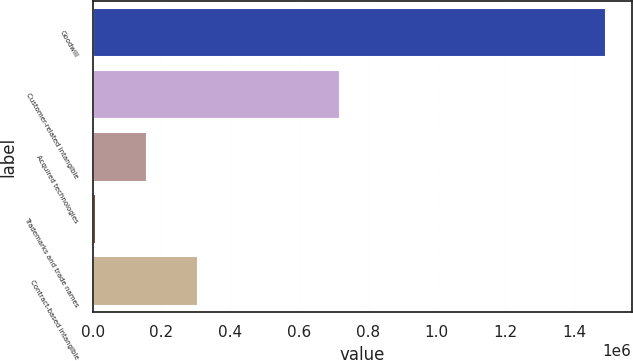Convert chart to OTSL. <chart><loc_0><loc_0><loc_500><loc_500><bar_chart><fcel>Goodwill<fcel>Customer-related intangible<fcel>Acquired technologies<fcel>Trademarks and trade names<fcel>Contract-based intangible<nl><fcel>1.49183e+06<fcel>718011<fcel>158883<fcel>10777<fcel>306988<nl></chart> 